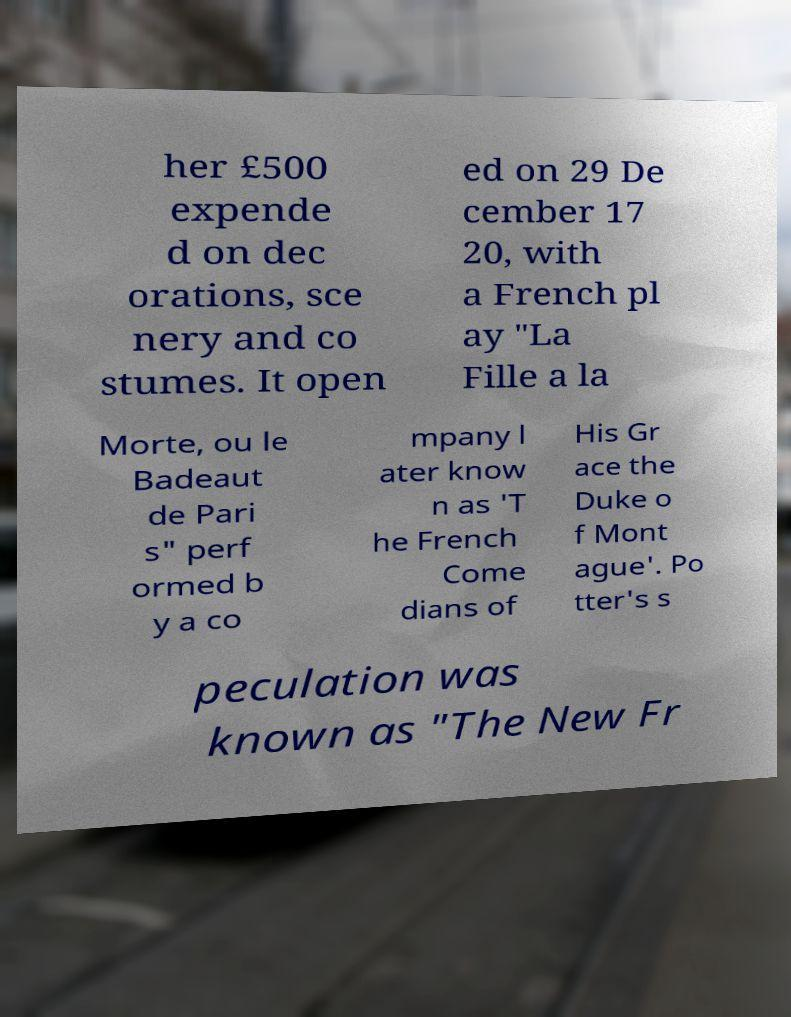I need the written content from this picture converted into text. Can you do that? her £500 expende d on dec orations, sce nery and co stumes. It open ed on 29 De cember 17 20, with a French pl ay "La Fille a la Morte, ou le Badeaut de Pari s" perf ormed b y a co mpany l ater know n as 'T he French Come dians of His Gr ace the Duke o f Mont ague'. Po tter's s peculation was known as "The New Fr 